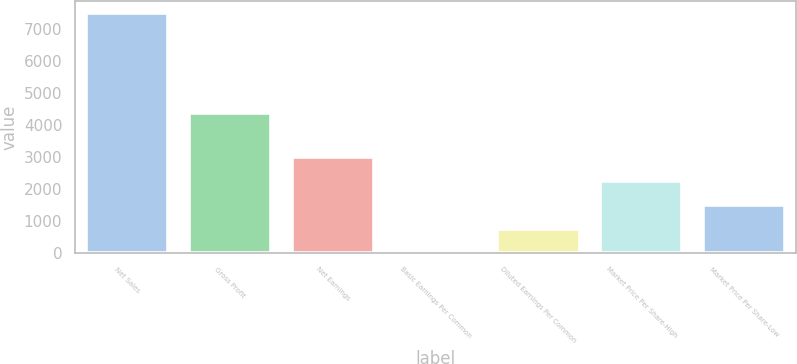Convert chart to OTSL. <chart><loc_0><loc_0><loc_500><loc_500><bar_chart><fcel>Net Sales<fcel>Gross Profit<fcel>Net Earnings<fcel>Basic Earnings Per Common<fcel>Diluted Earnings Per Common<fcel>Market Price Per Share-High<fcel>Market Price Per Share-Low<nl><fcel>7494.9<fcel>4365.9<fcel>2998.47<fcel>0.83<fcel>750.24<fcel>2249.06<fcel>1499.65<nl></chart> 